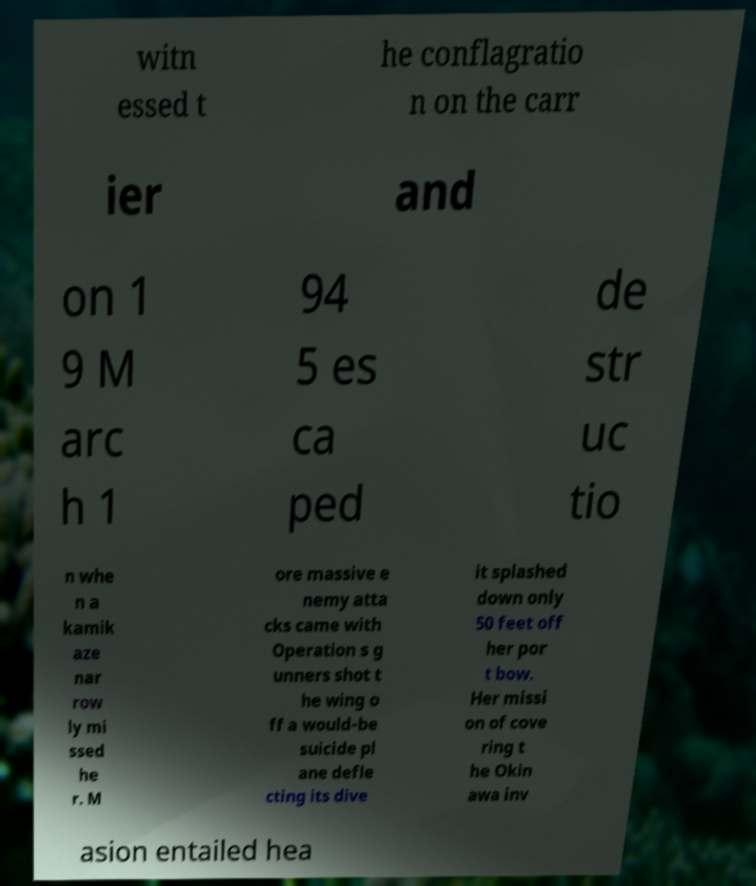Please read and relay the text visible in this image. What does it say? witn essed t he conflagratio n on the carr ier and on 1 9 M arc h 1 94 5 es ca ped de str uc tio n whe n a kamik aze nar row ly mi ssed he r. M ore massive e nemy atta cks came with Operation s g unners shot t he wing o ff a would-be suicide pl ane defle cting its dive it splashed down only 50 feet off her por t bow. Her missi on of cove ring t he Okin awa inv asion entailed hea 